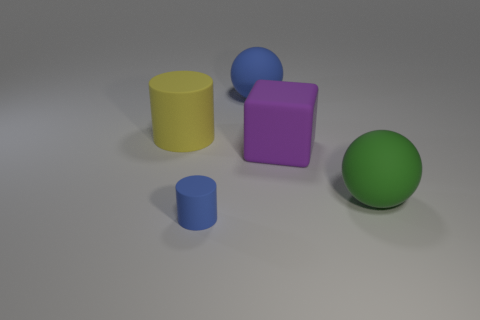If the light in the room increased, which object do you think would stand out the most? If the light intensity were increased, the object that would likely stand out the most would be the yellow rubber cylinder. Its bright color and reflective texture tend to catch more light, which would make it quite conspicuous compared to the other objects. 